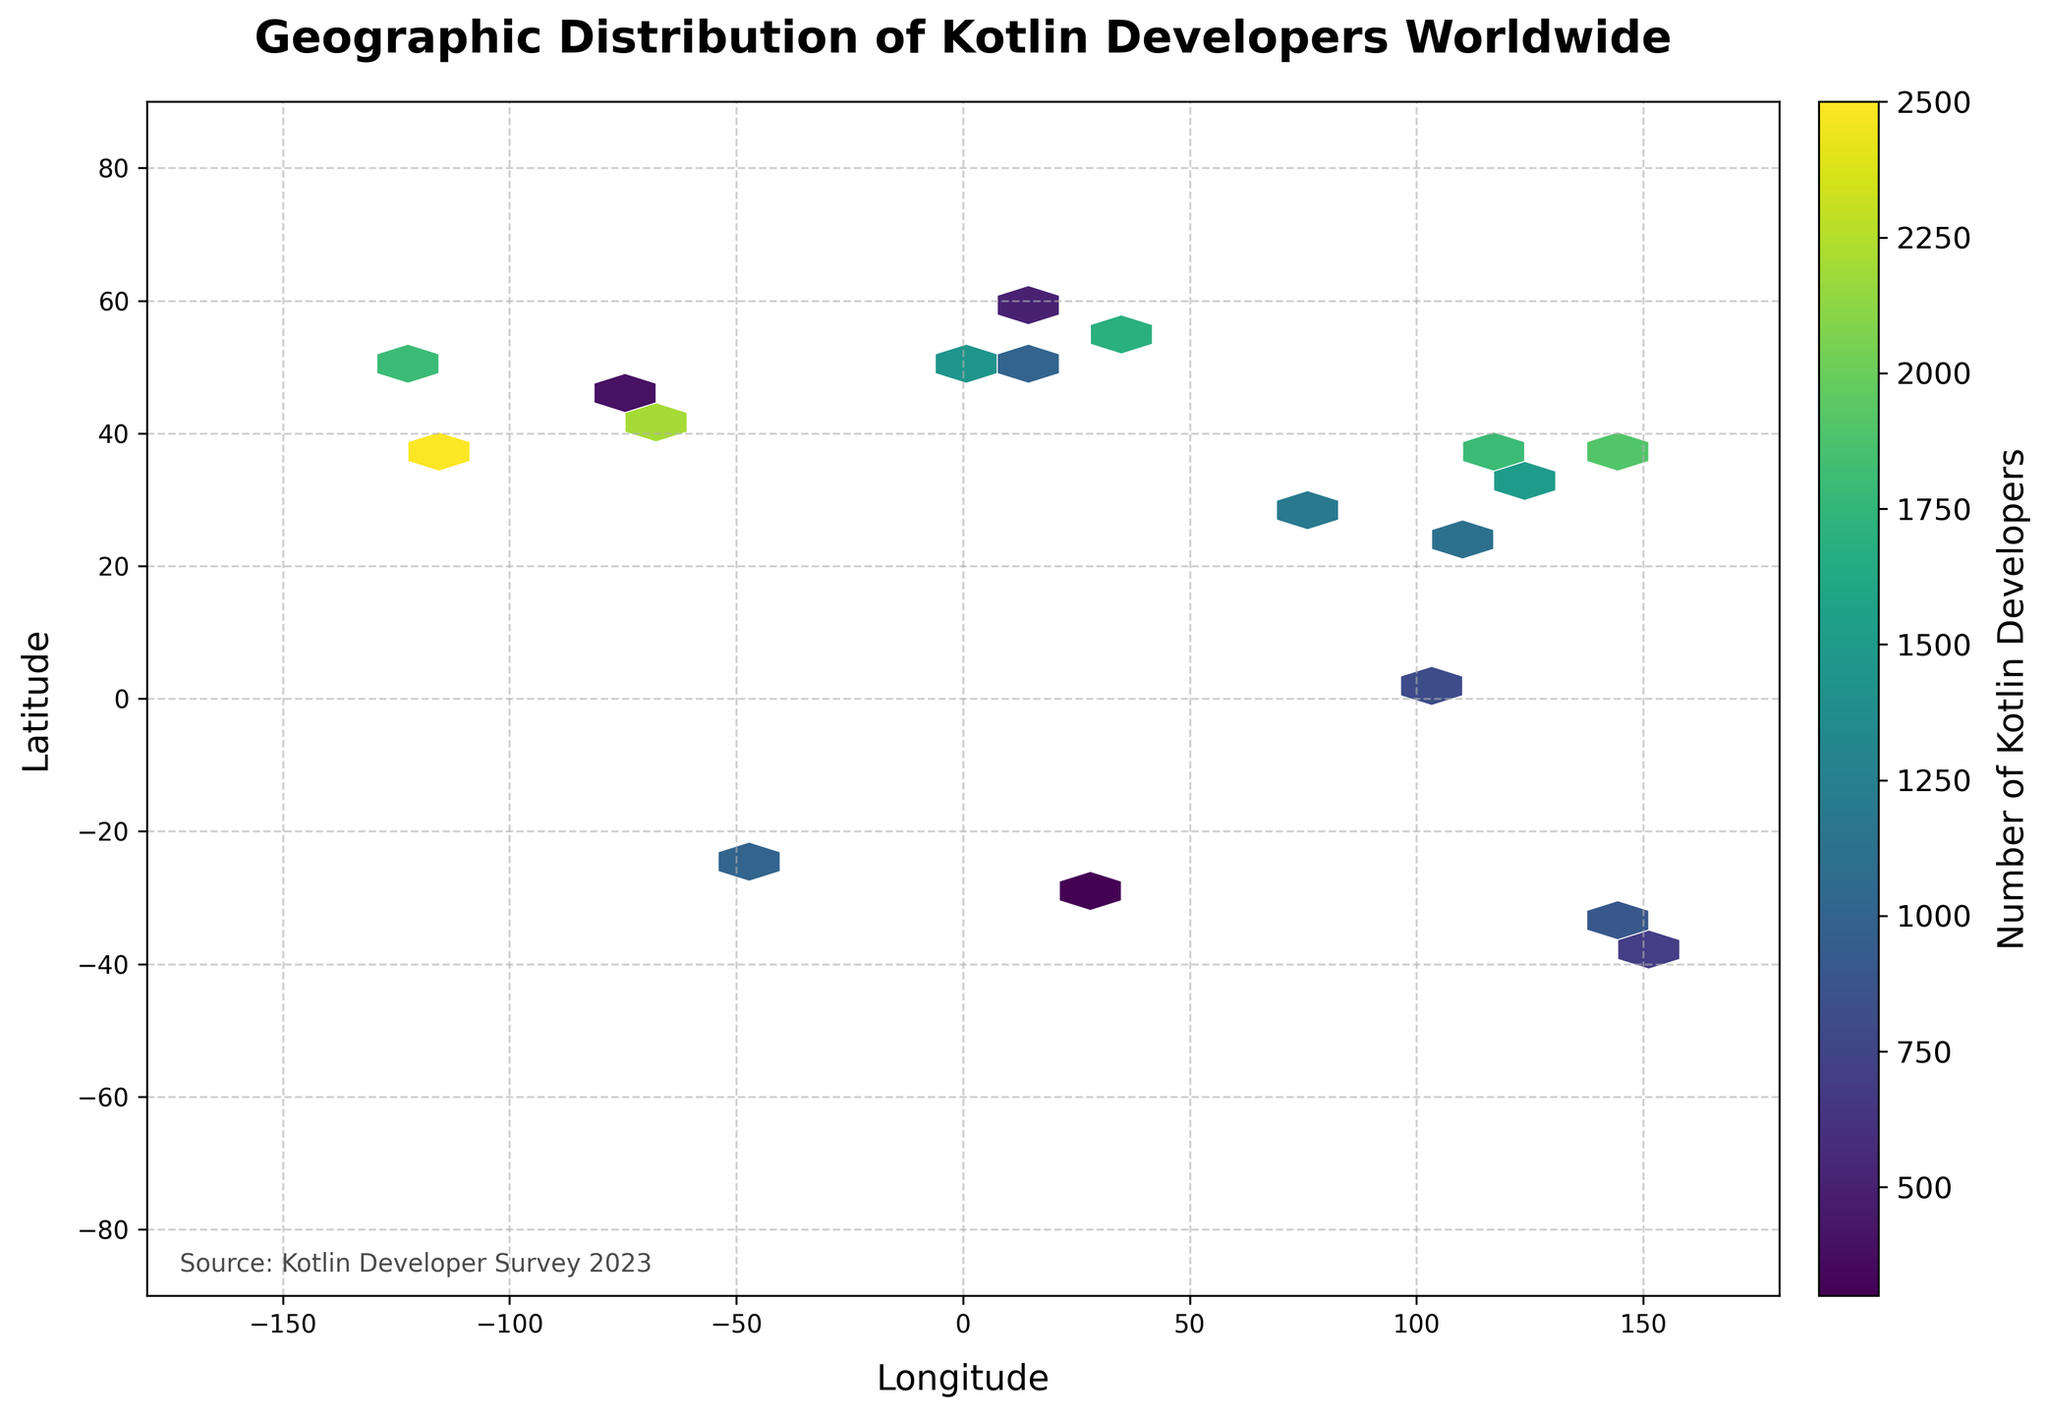What is the title of the hexbin plot? The title is placed at the top of the figure in a larger font and bold style: "Geographic Distribution of Kotlin Developers Worldwide".
Answer: Geographic Distribution of Kotlin Developers Worldwide Which axis represents the latitude in the plot? The latitude is represented by the vertical axis labeled "Latitude".
Answer: Vertical axis How is the color used in the plot? The color represents the number of Kotlin developers, with a colorbar labeled "Number of Kotlin Developers" showing the gradation.
Answer: The number of Kotlin developers Which region in the plot appears to have the highest density of Kotlin developers? The plot shows a denser color concentration around the coordinates of San Francisco, indicating a hotspot of Kotlin developers.
Answer: San Francisco What is the longitude range covered in the plot? Reading the horizontal axis labels, the longitude range covered by the hexbin plot spans from -180 to 180.
Answer: -180 to 180 How does the plot indicate the distribution of Kotlin developers in Asia compared to Europe? By comparing the color intensity in hexagons, Asia (especially around Tokyo, Beijing) shows higher density colors compared to Europe, indicating more Kotlin developers.
Answer: Asia has higher density What is the grid size used for the hexagon bins in the plot? Based on the visual spacing of the hexagons, the grid size is consistent with the specification in the code, which is 20.
Answer: 20 What would you infer about Kotlin developer spread in Australia? The plot reveals a lower density color in the region corresponding to Australia's coordinates, suggesting fewer Kotlin developers.
Answer: Fewer Kotlin developers How does the plot differentiate between the number of Kotlin developers in different regions? The plot uses varying color intensities within hexagons, brighter colors indicating higher numbers of Kotlin developers.
Answer: Varying color intensities What can be said about the distribution of Kotlin developers in the Southern Hemisphere? The Southern Hemisphere shows overall lower-density hexagons compared to the Northern Hemisphere, particularly in cities like Melbourne and Johannesburg.
Answer: Lower density 